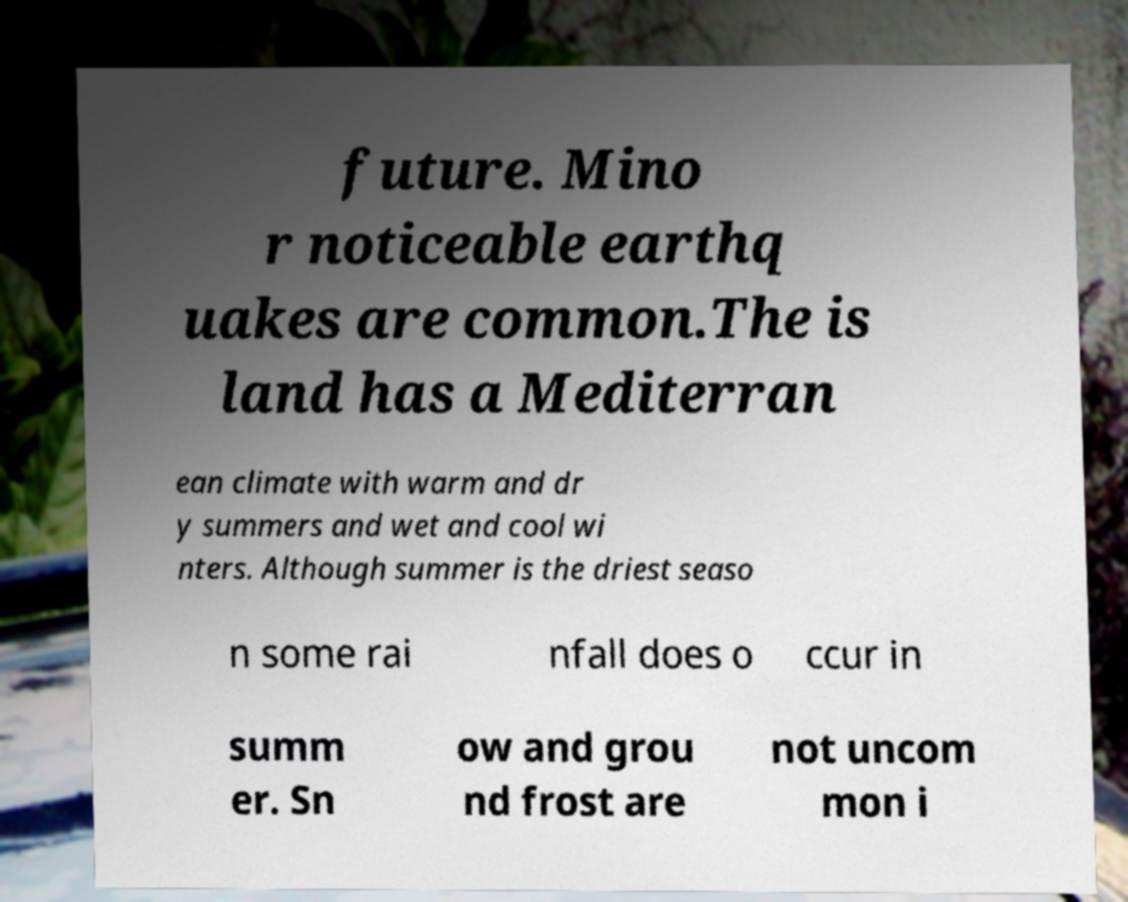Please read and relay the text visible in this image. What does it say? future. Mino r noticeable earthq uakes are common.The is land has a Mediterran ean climate with warm and dr y summers and wet and cool wi nters. Although summer is the driest seaso n some rai nfall does o ccur in summ er. Sn ow and grou nd frost are not uncom mon i 